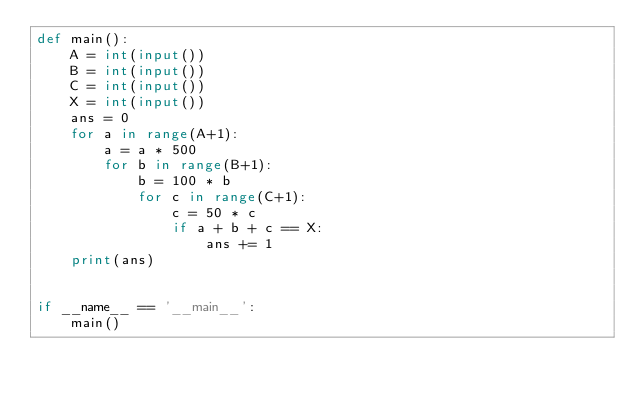Convert code to text. <code><loc_0><loc_0><loc_500><loc_500><_Python_>def main():
    A = int(input())
    B = int(input())
    C = int(input())
    X = int(input())
    ans = 0
    for a in range(A+1):
        a = a * 500
        for b in range(B+1):
            b = 100 * b
            for c in range(C+1):
                c = 50 * c
                if a + b + c == X:
                    ans += 1
    print(ans)


if __name__ == '__main__':
    main()
</code> 